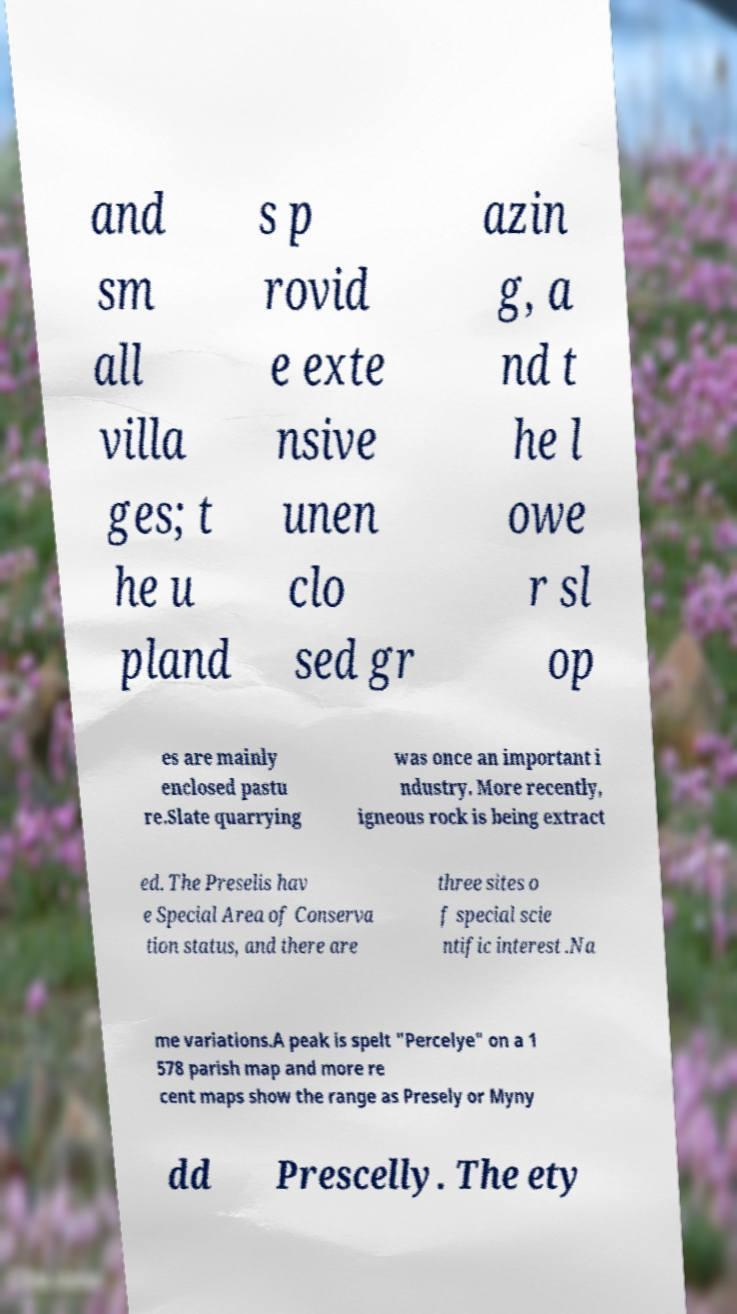For documentation purposes, I need the text within this image transcribed. Could you provide that? and sm all villa ges; t he u pland s p rovid e exte nsive unen clo sed gr azin g, a nd t he l owe r sl op es are mainly enclosed pastu re.Slate quarrying was once an important i ndustry. More recently, igneous rock is being extract ed. The Preselis hav e Special Area of Conserva tion status, and there are three sites o f special scie ntific interest .Na me variations.A peak is spelt "Percelye" on a 1 578 parish map and more re cent maps show the range as Presely or Myny dd Prescelly. The ety 